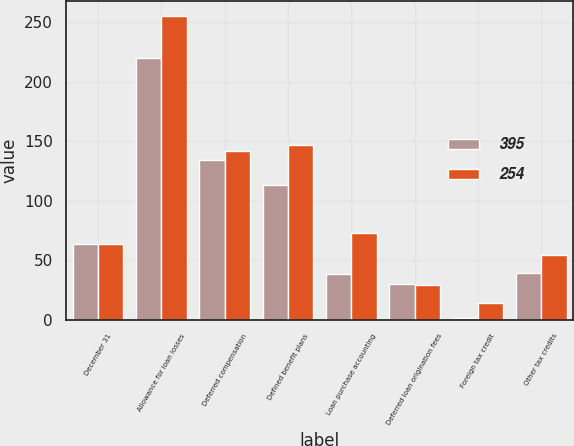Convert chart to OTSL. <chart><loc_0><loc_0><loc_500><loc_500><stacked_bar_chart><ecel><fcel>December 31<fcel>Allowance for loan losses<fcel>Deferred compensation<fcel>Defined benefit plans<fcel>Loan purchase accounting<fcel>Deferred loan origination fees<fcel>Foreign tax credit<fcel>Other tax credits<nl><fcel>395<fcel>63.5<fcel>220<fcel>134<fcel>113<fcel>38<fcel>30<fcel>1<fcel>39<nl><fcel>254<fcel>63.5<fcel>255<fcel>142<fcel>147<fcel>73<fcel>29<fcel>14<fcel>54<nl></chart> 